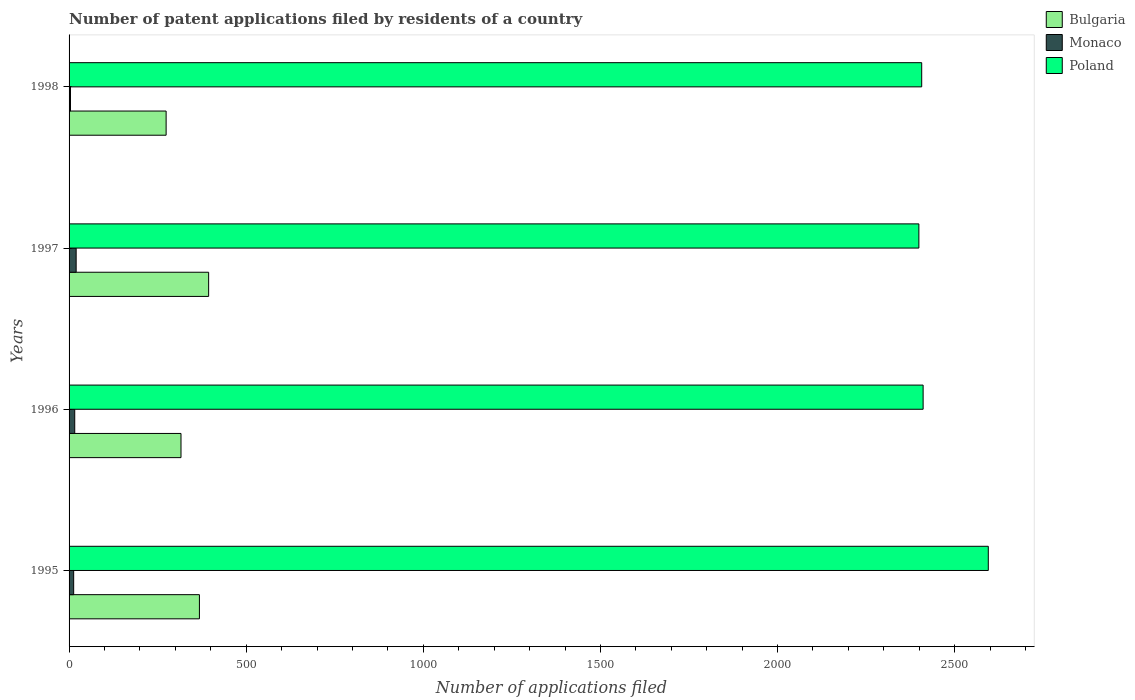How many different coloured bars are there?
Provide a short and direct response. 3. How many groups of bars are there?
Your answer should be very brief. 4. Are the number of bars per tick equal to the number of legend labels?
Your answer should be compact. Yes. Are the number of bars on each tick of the Y-axis equal?
Provide a short and direct response. Yes. How many bars are there on the 2nd tick from the top?
Provide a short and direct response. 3. How many bars are there on the 2nd tick from the bottom?
Your answer should be compact. 3. What is the number of applications filed in Bulgaria in 1998?
Your answer should be very brief. 274. Across all years, what is the maximum number of applications filed in Monaco?
Give a very brief answer. 20. Across all years, what is the minimum number of applications filed in Bulgaria?
Make the answer very short. 274. In which year was the number of applications filed in Poland maximum?
Ensure brevity in your answer.  1995. In which year was the number of applications filed in Poland minimum?
Your answer should be very brief. 1997. What is the total number of applications filed in Poland in the graph?
Your response must be concise. 9812. What is the difference between the number of applications filed in Poland in 1995 and that in 1998?
Offer a very short reply. 188. What is the difference between the number of applications filed in Monaco in 1996 and the number of applications filed in Bulgaria in 1997?
Give a very brief answer. -378. What is the average number of applications filed in Poland per year?
Keep it short and to the point. 2453. In the year 1996, what is the difference between the number of applications filed in Poland and number of applications filed in Monaco?
Keep it short and to the point. 2395. What is the ratio of the number of applications filed in Poland in 1996 to that in 1997?
Keep it short and to the point. 1.01. Is the number of applications filed in Bulgaria in 1996 less than that in 1998?
Your answer should be compact. No. What is the difference between the highest and the lowest number of applications filed in Monaco?
Make the answer very short. 16. In how many years, is the number of applications filed in Poland greater than the average number of applications filed in Poland taken over all years?
Your answer should be very brief. 1. Is the sum of the number of applications filed in Monaco in 1995 and 1998 greater than the maximum number of applications filed in Poland across all years?
Provide a succinct answer. No. What does the 1st bar from the bottom in 1996 represents?
Make the answer very short. Bulgaria. How many bars are there?
Your answer should be compact. 12. What is the difference between two consecutive major ticks on the X-axis?
Provide a succinct answer. 500. Are the values on the major ticks of X-axis written in scientific E-notation?
Your answer should be very brief. No. Does the graph contain any zero values?
Offer a very short reply. No. Does the graph contain grids?
Offer a very short reply. No. Where does the legend appear in the graph?
Your answer should be compact. Top right. How many legend labels are there?
Provide a short and direct response. 3. What is the title of the graph?
Offer a terse response. Number of patent applications filed by residents of a country. Does "United States" appear as one of the legend labels in the graph?
Make the answer very short. No. What is the label or title of the X-axis?
Offer a very short reply. Number of applications filed. What is the Number of applications filed of Bulgaria in 1995?
Ensure brevity in your answer.  368. What is the Number of applications filed of Monaco in 1995?
Your answer should be compact. 13. What is the Number of applications filed of Poland in 1995?
Ensure brevity in your answer.  2595. What is the Number of applications filed in Bulgaria in 1996?
Give a very brief answer. 316. What is the Number of applications filed in Poland in 1996?
Your answer should be very brief. 2411. What is the Number of applications filed in Bulgaria in 1997?
Provide a short and direct response. 394. What is the Number of applications filed in Poland in 1997?
Provide a succinct answer. 2399. What is the Number of applications filed of Bulgaria in 1998?
Offer a terse response. 274. What is the Number of applications filed of Monaco in 1998?
Offer a very short reply. 4. What is the Number of applications filed of Poland in 1998?
Keep it short and to the point. 2407. Across all years, what is the maximum Number of applications filed of Bulgaria?
Ensure brevity in your answer.  394. Across all years, what is the maximum Number of applications filed of Poland?
Offer a very short reply. 2595. Across all years, what is the minimum Number of applications filed of Bulgaria?
Give a very brief answer. 274. Across all years, what is the minimum Number of applications filed of Monaco?
Keep it short and to the point. 4. Across all years, what is the minimum Number of applications filed of Poland?
Offer a very short reply. 2399. What is the total Number of applications filed of Bulgaria in the graph?
Offer a terse response. 1352. What is the total Number of applications filed of Poland in the graph?
Ensure brevity in your answer.  9812. What is the difference between the Number of applications filed in Poland in 1995 and that in 1996?
Offer a terse response. 184. What is the difference between the Number of applications filed of Bulgaria in 1995 and that in 1997?
Ensure brevity in your answer.  -26. What is the difference between the Number of applications filed in Poland in 1995 and that in 1997?
Ensure brevity in your answer.  196. What is the difference between the Number of applications filed of Bulgaria in 1995 and that in 1998?
Give a very brief answer. 94. What is the difference between the Number of applications filed in Poland in 1995 and that in 1998?
Make the answer very short. 188. What is the difference between the Number of applications filed of Bulgaria in 1996 and that in 1997?
Your response must be concise. -78. What is the difference between the Number of applications filed of Poland in 1996 and that in 1997?
Provide a short and direct response. 12. What is the difference between the Number of applications filed in Bulgaria in 1997 and that in 1998?
Your answer should be very brief. 120. What is the difference between the Number of applications filed of Monaco in 1997 and that in 1998?
Keep it short and to the point. 16. What is the difference between the Number of applications filed in Bulgaria in 1995 and the Number of applications filed in Monaco in 1996?
Ensure brevity in your answer.  352. What is the difference between the Number of applications filed of Bulgaria in 1995 and the Number of applications filed of Poland in 1996?
Provide a succinct answer. -2043. What is the difference between the Number of applications filed in Monaco in 1995 and the Number of applications filed in Poland in 1996?
Keep it short and to the point. -2398. What is the difference between the Number of applications filed of Bulgaria in 1995 and the Number of applications filed of Monaco in 1997?
Your answer should be compact. 348. What is the difference between the Number of applications filed in Bulgaria in 1995 and the Number of applications filed in Poland in 1997?
Provide a short and direct response. -2031. What is the difference between the Number of applications filed in Monaco in 1995 and the Number of applications filed in Poland in 1997?
Provide a succinct answer. -2386. What is the difference between the Number of applications filed of Bulgaria in 1995 and the Number of applications filed of Monaco in 1998?
Offer a terse response. 364. What is the difference between the Number of applications filed in Bulgaria in 1995 and the Number of applications filed in Poland in 1998?
Give a very brief answer. -2039. What is the difference between the Number of applications filed in Monaco in 1995 and the Number of applications filed in Poland in 1998?
Your answer should be compact. -2394. What is the difference between the Number of applications filed in Bulgaria in 1996 and the Number of applications filed in Monaco in 1997?
Give a very brief answer. 296. What is the difference between the Number of applications filed of Bulgaria in 1996 and the Number of applications filed of Poland in 1997?
Offer a very short reply. -2083. What is the difference between the Number of applications filed in Monaco in 1996 and the Number of applications filed in Poland in 1997?
Make the answer very short. -2383. What is the difference between the Number of applications filed in Bulgaria in 1996 and the Number of applications filed in Monaco in 1998?
Give a very brief answer. 312. What is the difference between the Number of applications filed of Bulgaria in 1996 and the Number of applications filed of Poland in 1998?
Give a very brief answer. -2091. What is the difference between the Number of applications filed in Monaco in 1996 and the Number of applications filed in Poland in 1998?
Keep it short and to the point. -2391. What is the difference between the Number of applications filed of Bulgaria in 1997 and the Number of applications filed of Monaco in 1998?
Make the answer very short. 390. What is the difference between the Number of applications filed in Bulgaria in 1997 and the Number of applications filed in Poland in 1998?
Offer a very short reply. -2013. What is the difference between the Number of applications filed in Monaco in 1997 and the Number of applications filed in Poland in 1998?
Your answer should be very brief. -2387. What is the average Number of applications filed of Bulgaria per year?
Ensure brevity in your answer.  338. What is the average Number of applications filed in Monaco per year?
Your response must be concise. 13.25. What is the average Number of applications filed of Poland per year?
Ensure brevity in your answer.  2453. In the year 1995, what is the difference between the Number of applications filed in Bulgaria and Number of applications filed in Monaco?
Offer a terse response. 355. In the year 1995, what is the difference between the Number of applications filed of Bulgaria and Number of applications filed of Poland?
Give a very brief answer. -2227. In the year 1995, what is the difference between the Number of applications filed in Monaco and Number of applications filed in Poland?
Provide a short and direct response. -2582. In the year 1996, what is the difference between the Number of applications filed in Bulgaria and Number of applications filed in Monaco?
Give a very brief answer. 300. In the year 1996, what is the difference between the Number of applications filed of Bulgaria and Number of applications filed of Poland?
Your response must be concise. -2095. In the year 1996, what is the difference between the Number of applications filed of Monaco and Number of applications filed of Poland?
Make the answer very short. -2395. In the year 1997, what is the difference between the Number of applications filed in Bulgaria and Number of applications filed in Monaco?
Provide a succinct answer. 374. In the year 1997, what is the difference between the Number of applications filed of Bulgaria and Number of applications filed of Poland?
Give a very brief answer. -2005. In the year 1997, what is the difference between the Number of applications filed in Monaco and Number of applications filed in Poland?
Give a very brief answer. -2379. In the year 1998, what is the difference between the Number of applications filed in Bulgaria and Number of applications filed in Monaco?
Offer a very short reply. 270. In the year 1998, what is the difference between the Number of applications filed in Bulgaria and Number of applications filed in Poland?
Offer a very short reply. -2133. In the year 1998, what is the difference between the Number of applications filed in Monaco and Number of applications filed in Poland?
Your answer should be compact. -2403. What is the ratio of the Number of applications filed of Bulgaria in 1995 to that in 1996?
Provide a short and direct response. 1.16. What is the ratio of the Number of applications filed of Monaco in 1995 to that in 1996?
Offer a terse response. 0.81. What is the ratio of the Number of applications filed in Poland in 1995 to that in 1996?
Your response must be concise. 1.08. What is the ratio of the Number of applications filed in Bulgaria in 1995 to that in 1997?
Your answer should be compact. 0.93. What is the ratio of the Number of applications filed of Monaco in 1995 to that in 1997?
Give a very brief answer. 0.65. What is the ratio of the Number of applications filed in Poland in 1995 to that in 1997?
Make the answer very short. 1.08. What is the ratio of the Number of applications filed of Bulgaria in 1995 to that in 1998?
Provide a short and direct response. 1.34. What is the ratio of the Number of applications filed in Monaco in 1995 to that in 1998?
Make the answer very short. 3.25. What is the ratio of the Number of applications filed in Poland in 1995 to that in 1998?
Ensure brevity in your answer.  1.08. What is the ratio of the Number of applications filed of Bulgaria in 1996 to that in 1997?
Give a very brief answer. 0.8. What is the ratio of the Number of applications filed in Bulgaria in 1996 to that in 1998?
Ensure brevity in your answer.  1.15. What is the ratio of the Number of applications filed of Bulgaria in 1997 to that in 1998?
Offer a terse response. 1.44. What is the ratio of the Number of applications filed of Poland in 1997 to that in 1998?
Give a very brief answer. 1. What is the difference between the highest and the second highest Number of applications filed in Bulgaria?
Ensure brevity in your answer.  26. What is the difference between the highest and the second highest Number of applications filed of Poland?
Your answer should be compact. 184. What is the difference between the highest and the lowest Number of applications filed in Bulgaria?
Your answer should be very brief. 120. What is the difference between the highest and the lowest Number of applications filed of Monaco?
Ensure brevity in your answer.  16. What is the difference between the highest and the lowest Number of applications filed in Poland?
Offer a very short reply. 196. 